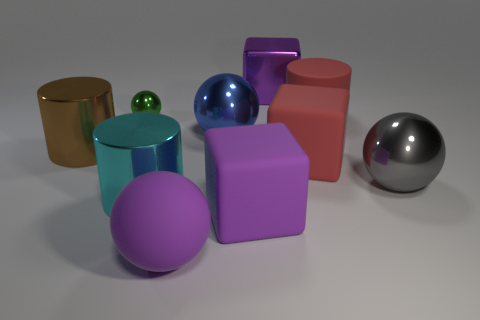What can you tell me about the colors in the image? The image showcases a delightful palette of colors with multiple hues. There are objects in vibrant colors like red, blue, and purple, and others in more subdued shades like the gold and silver metallic colors. The color distribution is evenly balanced, providing a pleasing visual diversity without any single color dominating the scene. 